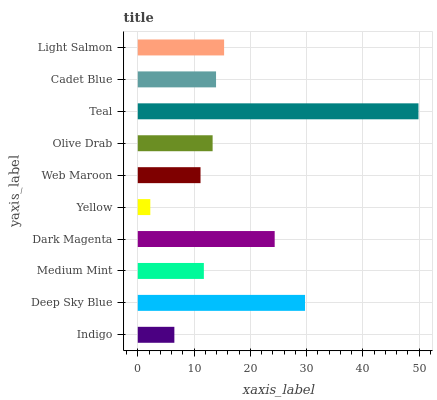Is Yellow the minimum?
Answer yes or no. Yes. Is Teal the maximum?
Answer yes or no. Yes. Is Deep Sky Blue the minimum?
Answer yes or no. No. Is Deep Sky Blue the maximum?
Answer yes or no. No. Is Deep Sky Blue greater than Indigo?
Answer yes or no. Yes. Is Indigo less than Deep Sky Blue?
Answer yes or no. Yes. Is Indigo greater than Deep Sky Blue?
Answer yes or no. No. Is Deep Sky Blue less than Indigo?
Answer yes or no. No. Is Cadet Blue the high median?
Answer yes or no. Yes. Is Olive Drab the low median?
Answer yes or no. Yes. Is Teal the high median?
Answer yes or no. No. Is Medium Mint the low median?
Answer yes or no. No. 